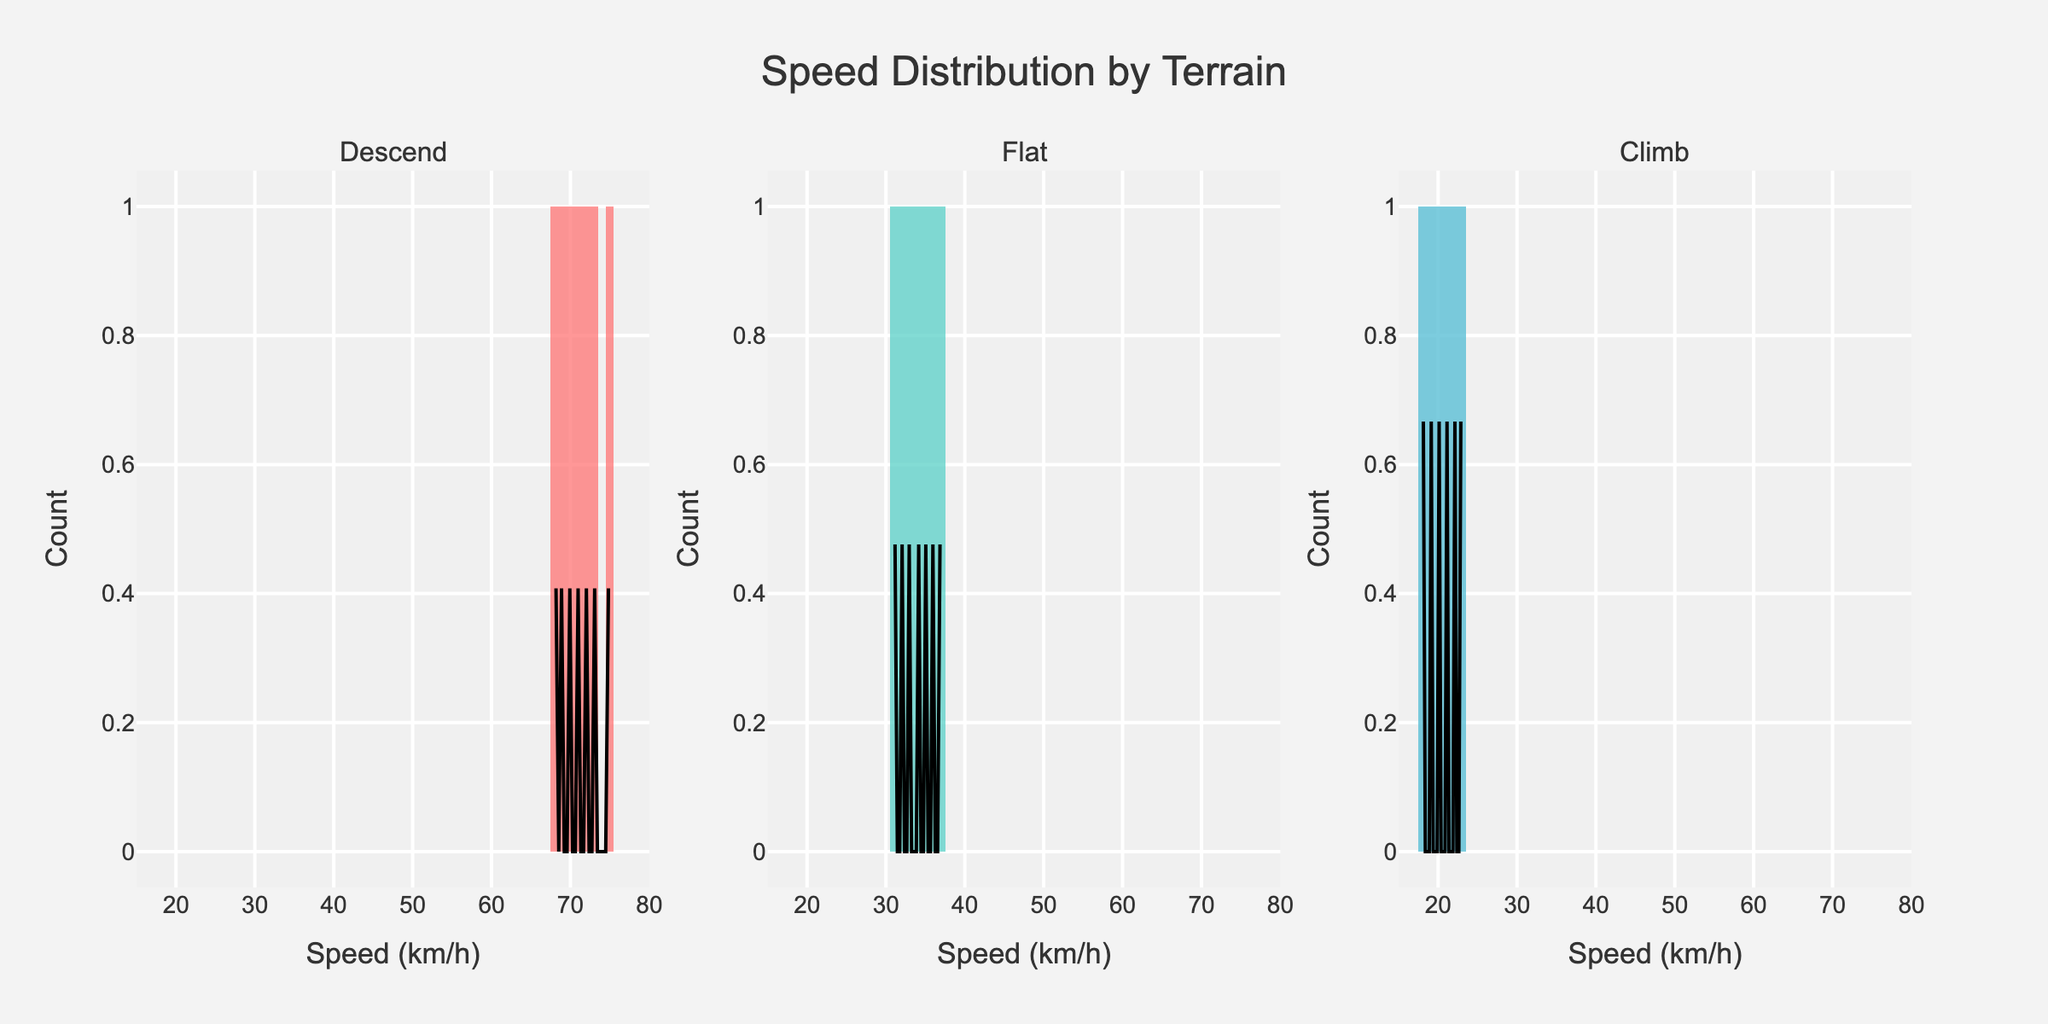What's the title of the figure? The title of the figure is displayed at the top center of the plot and reads "Speed Distribution by Terrain"
Answer: Speed Distribution by Terrain What is the range of speeds displayed on the x-axis? The x-axis shows the range of speeds. The values start at 15 km/h and go up to 80 km/h
Answer: 15 to 80 km/h Which terrain shows the highest speed among cyclists? By looking at the highest speed data point on each terrain's histogram, "Descend" shows the highest speed with values reaching up to 75 km/h
Answer: Descend How many subplots are there in the figure? The figure is divided into multiple sections, each representing a category. There are three separate sections in this figure, one for each terrain
Answer: 3 What's the most common speed range for cyclists on flat terrain according to the histogram? By observing the largest bars in the Flat subplot, the most common speed range for cyclists on flat terrain appears to be between 30 and 40 km/h
Answer: 30-40 km/h How does the speed distribution of "Climb" terrain compare to "Descend"? The comparison involves looking at both the histograms and KDE curves. "Climb" terrain has lower speeds, typically ranging from 18 to 23 km/h, while "Descend" terrain ranges from around 68 to 75 km/h, indicating much higher speeds in descending terrain
Answer: Climb terrain has notably lower speeds than Descend terrain Which terrain has the largest spread of speed values? Spread of speed values can be seen by the range of the histogram bars and the KDE curve. "Descend" terrain spans from around 68 to 75 km/h, which is a larger spread compared to other terrains
Answer: Descend What is the color used for the histogram bars of the "Flat" terrain? The "Flat" terrain's histogram bars can be identified by their color in the figure, which is teal
Answer: Teal 